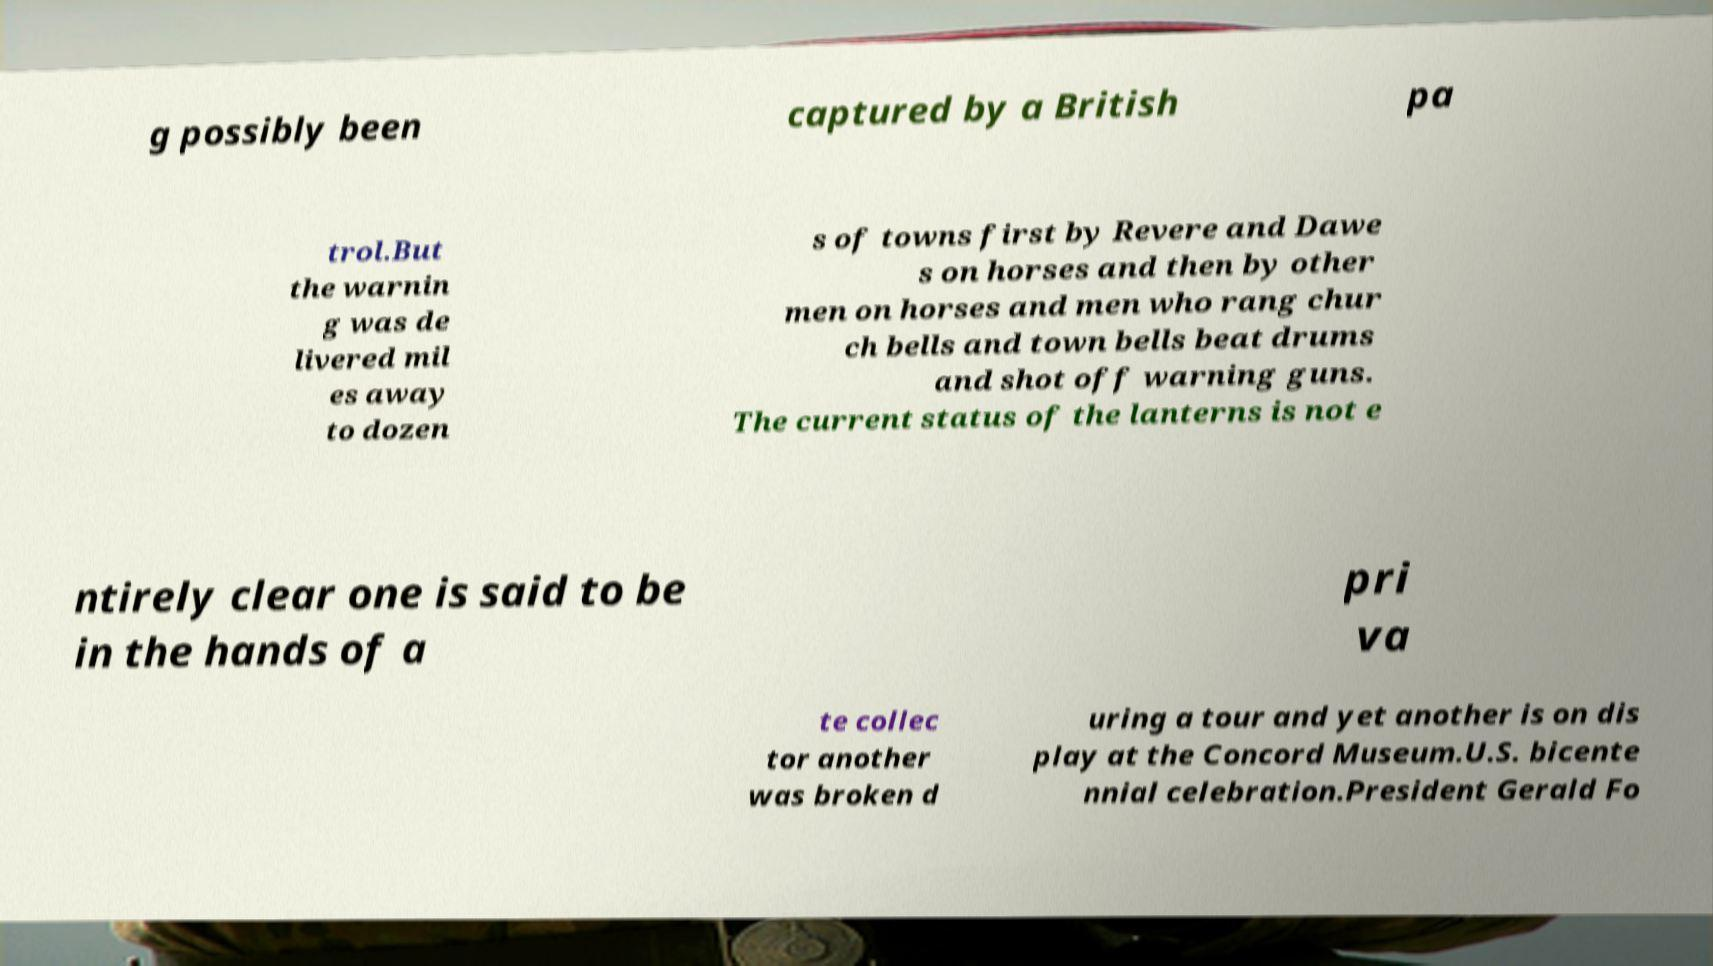What messages or text are displayed in this image? I need them in a readable, typed format. g possibly been captured by a British pa trol.But the warnin g was de livered mil es away to dozen s of towns first by Revere and Dawe s on horses and then by other men on horses and men who rang chur ch bells and town bells beat drums and shot off warning guns. The current status of the lanterns is not e ntirely clear one is said to be in the hands of a pri va te collec tor another was broken d uring a tour and yet another is on dis play at the Concord Museum.U.S. bicente nnial celebration.President Gerald Fo 